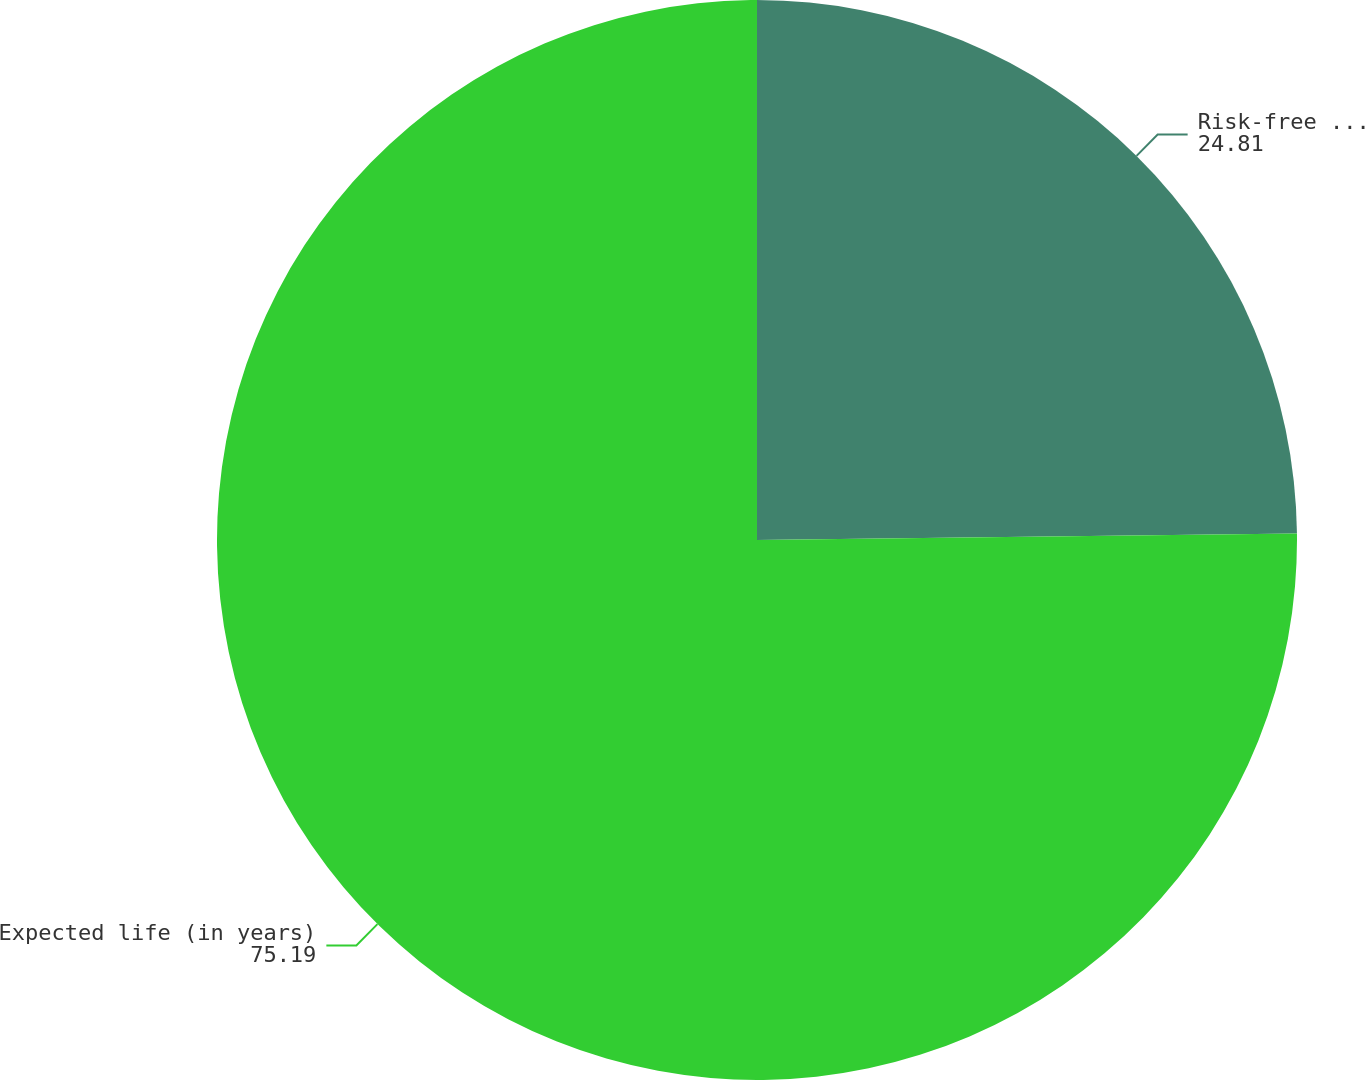Convert chart to OTSL. <chart><loc_0><loc_0><loc_500><loc_500><pie_chart><fcel>Risk-free interest rate<fcel>Expected life (in years)<nl><fcel>24.81%<fcel>75.19%<nl></chart> 